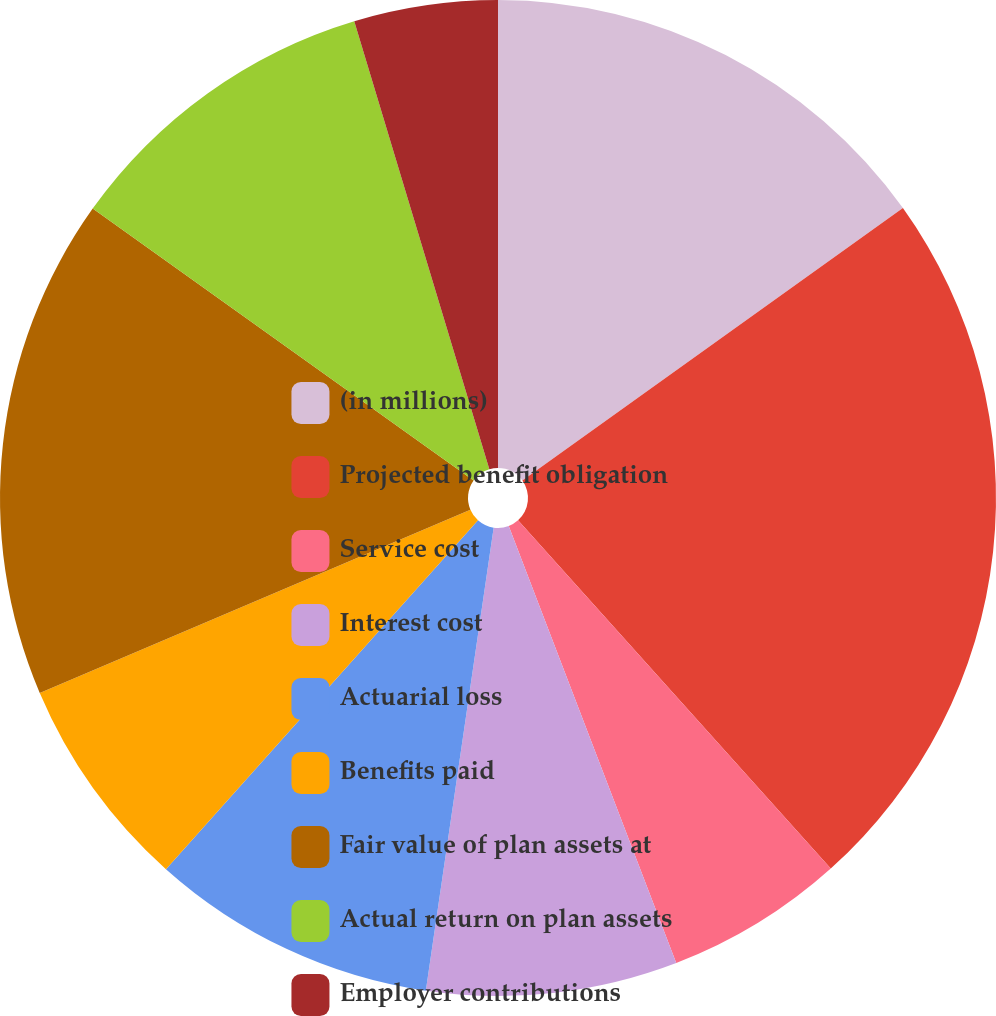Convert chart. <chart><loc_0><loc_0><loc_500><loc_500><pie_chart><fcel>(in millions)<fcel>Projected benefit obligation<fcel>Service cost<fcel>Interest cost<fcel>Actuarial loss<fcel>Benefits paid<fcel>Fair value of plan assets at<fcel>Actual return on plan assets<fcel>Employer contributions<nl><fcel>15.11%<fcel>23.24%<fcel>5.82%<fcel>8.14%<fcel>9.3%<fcel>6.98%<fcel>16.27%<fcel>10.47%<fcel>4.66%<nl></chart> 